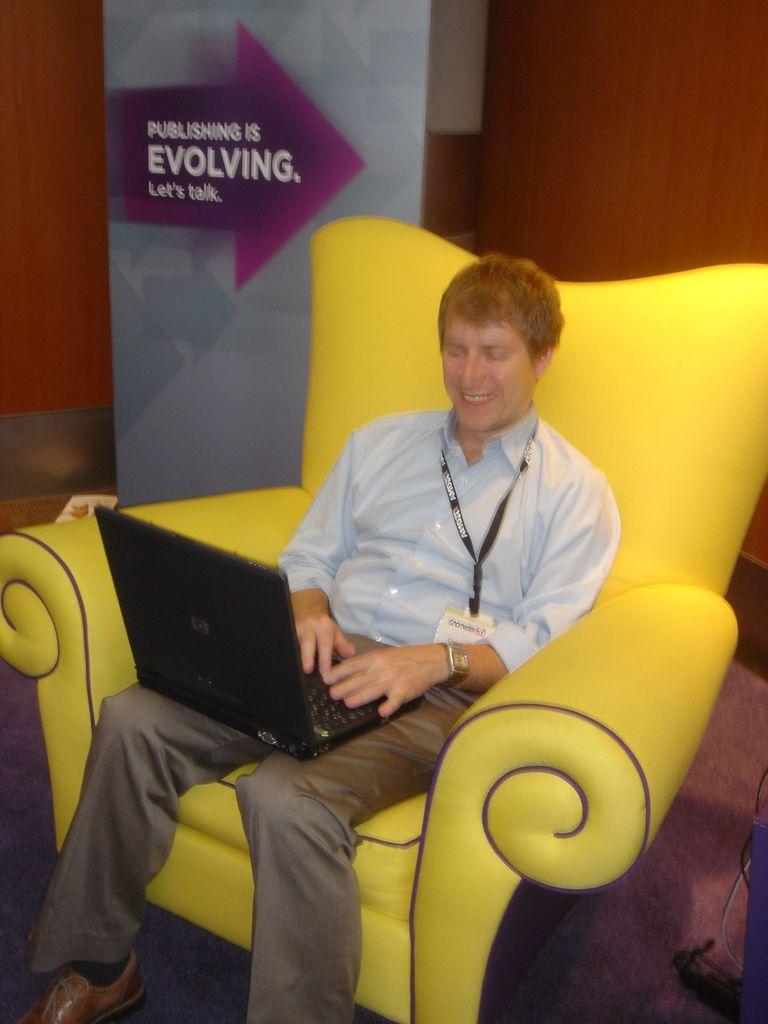Please provide a concise description of this image. This person sitting on the chair and smiling and holding laptop and wear tag. On the background we can see banner,wall. 